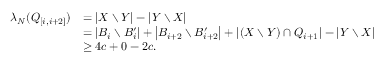<formula> <loc_0><loc_0><loc_500><loc_500>\begin{array} { r l } { \lambda _ { N } ( Q _ { [ i , i + 2 ] } ) } & { = \left | X \ Y \right | - \left | Y \ X \right | } \\ & { = \left | B _ { i } \ B _ { i } ^ { \prime } \right | + \left | B _ { i + 2 } \ B _ { i + 2 } ^ { \prime } \right | + \left | ( X \ Y ) \cap Q _ { i + 1 } \right | - \left | Y \ X \right | } \\ & { \geq 4 c + 0 - 2 c . } \end{array}</formula> 